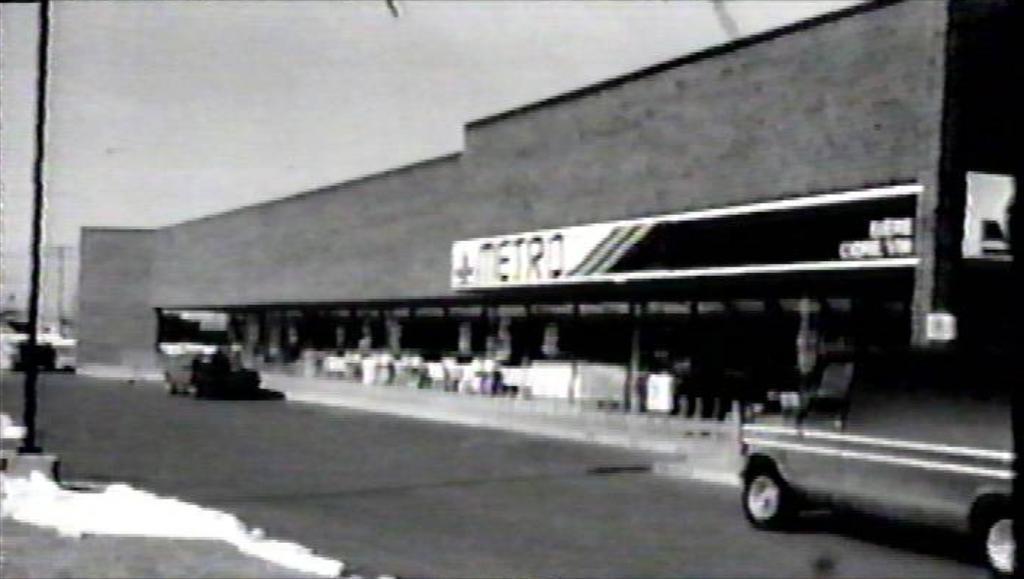Could you give a brief overview of what you see in this image? This is a black and white image. The picture is blurred. In the center of the picture there is a building. In the foreground of the picture there are cars and a pole, on the road. 